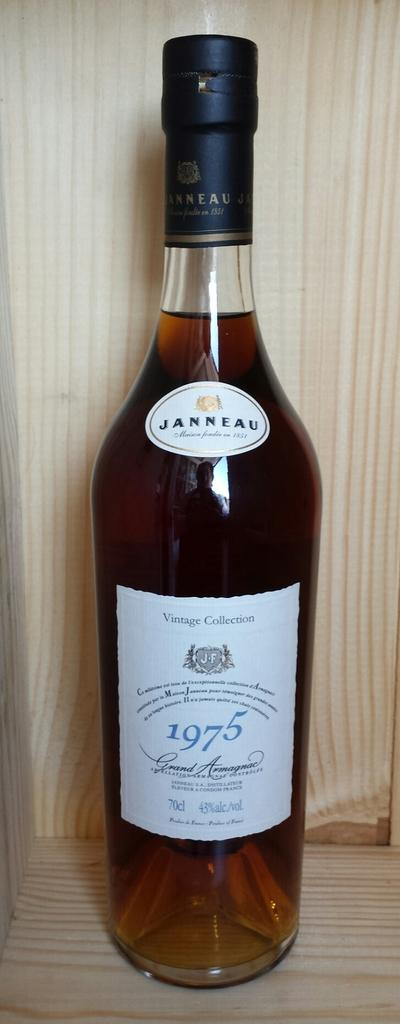<image>
Summarize the visual content of the image. A bottle of amber colored Janneau Grand Armagnac with a white label and black capping. 